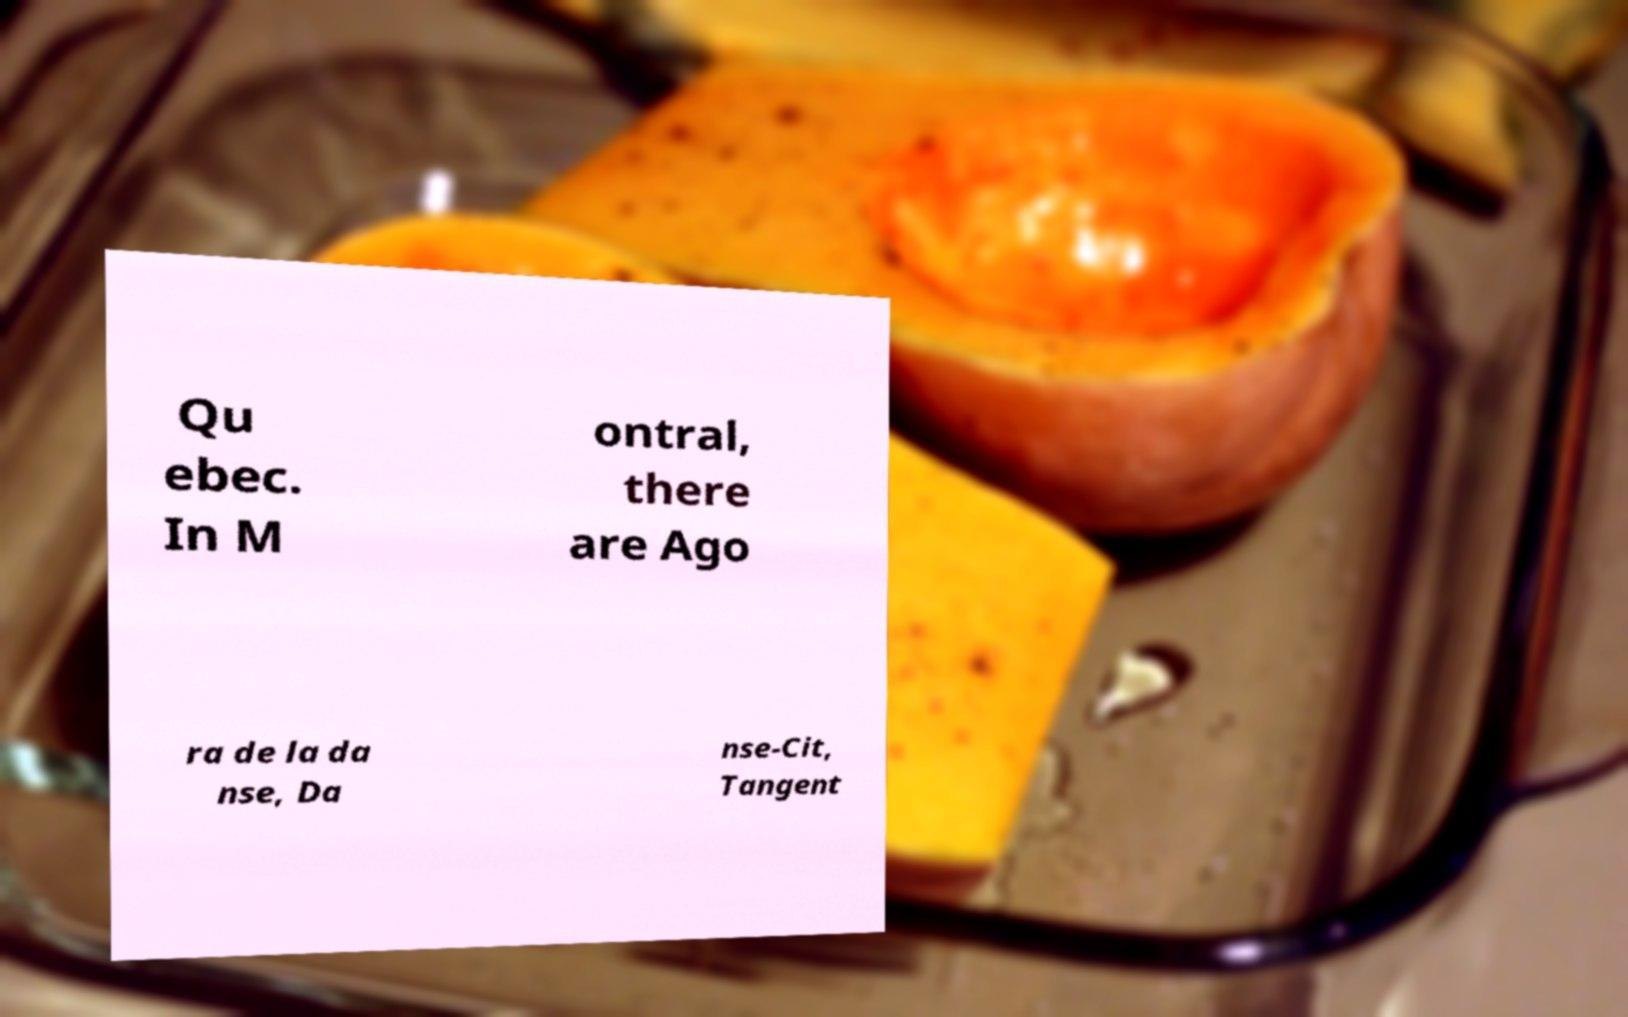Please read and relay the text visible in this image. What does it say? Qu ebec. In M ontral, there are Ago ra de la da nse, Da nse-Cit, Tangent 